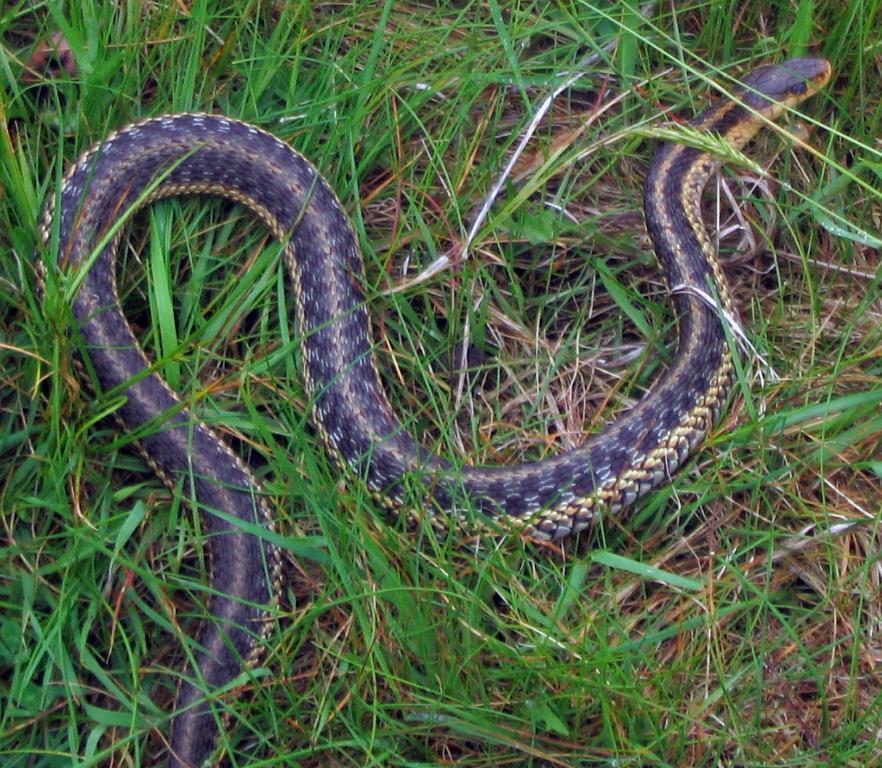Could you give a brief overview of what you see in this image? In this image I can see a snake which is in black and cream color, and I can also see grass in green color. 